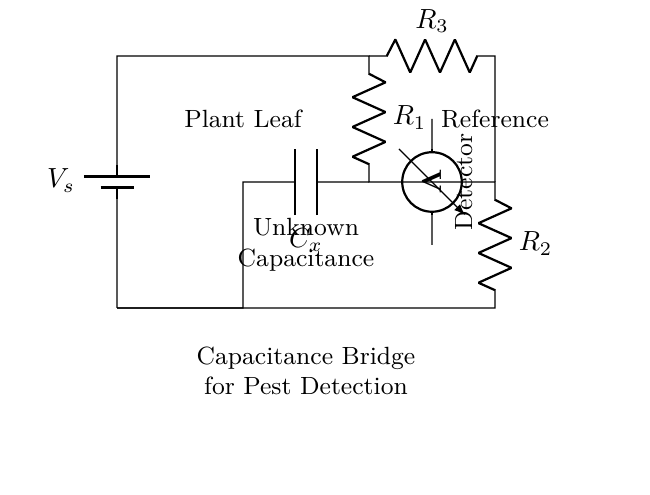What is the source voltage in this circuit? The source voltage, labeled as V_s, is represented at the top of the battery in the circuit. It supplies the electrical energy to the other components.
Answer: V_s What components are used in the circuit? The circuit contains resistors R1, R2, R3, a capacitor C_x, a voltmeter, and a battery. These components each perform specific functions in the capacitance bridge for pest detection.
Answer: R1, R2, R3, C_x, voltmeter, battery What is the function of the capacitor in this circuit? The capacitor, labeled as C_x, is used to detect the unknown capacitance which can change based on the presence of pests on the plant leaf. This change in capacitance is what the circuit is designed to measure.
Answer: Detect pest presence What does the voltmeter measure in this circuit? The voltmeter, indicated in the circuit diagram, measures the voltage across a section of the circuit, specifically the unknown capacitance. This measurement is crucial for determining any changes related to pest presence.
Answer: Unknown voltage How are R1 and R2 connected in the circuit? R1 and R2 are connected in parallel to each other, as seen from the diagram, providing two pathways for the current. This arrangement plays a key role in balancing the bridge circuit for accurate capacitance detection.
Answer: Parallel What role does the plant leaf play in this circuit? The plant leaf acts as an unknown capacitor (C_x) in the circuit, where its capacitance changes due to the presence of pests. The circuit is designed to detect these changes in capacitance.
Answer: Unknown capacitance 